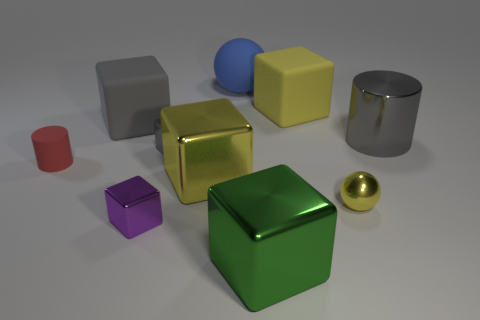How many objects are there in the image, and can you categorize them by color? There are a total of seven objects in the image. Categorizing them by color, we have: one red and one pink cylinder, one blue sphere, one purple and one green cube, and one yellow and one gray metallic cube. Interestingly, the cubes showcase three different finishes: metallic, shiny, and matte. 